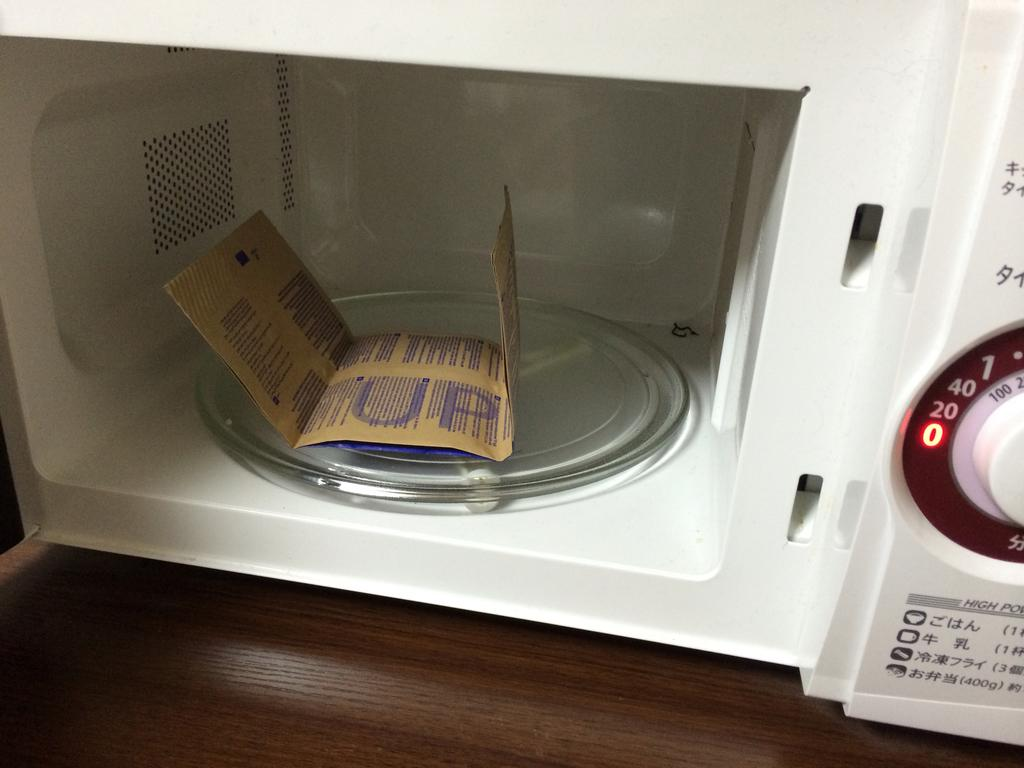<image>
Share a concise interpretation of the image provided. unpopped bag of popcorn in open microwave and timer highlighting the number 0 